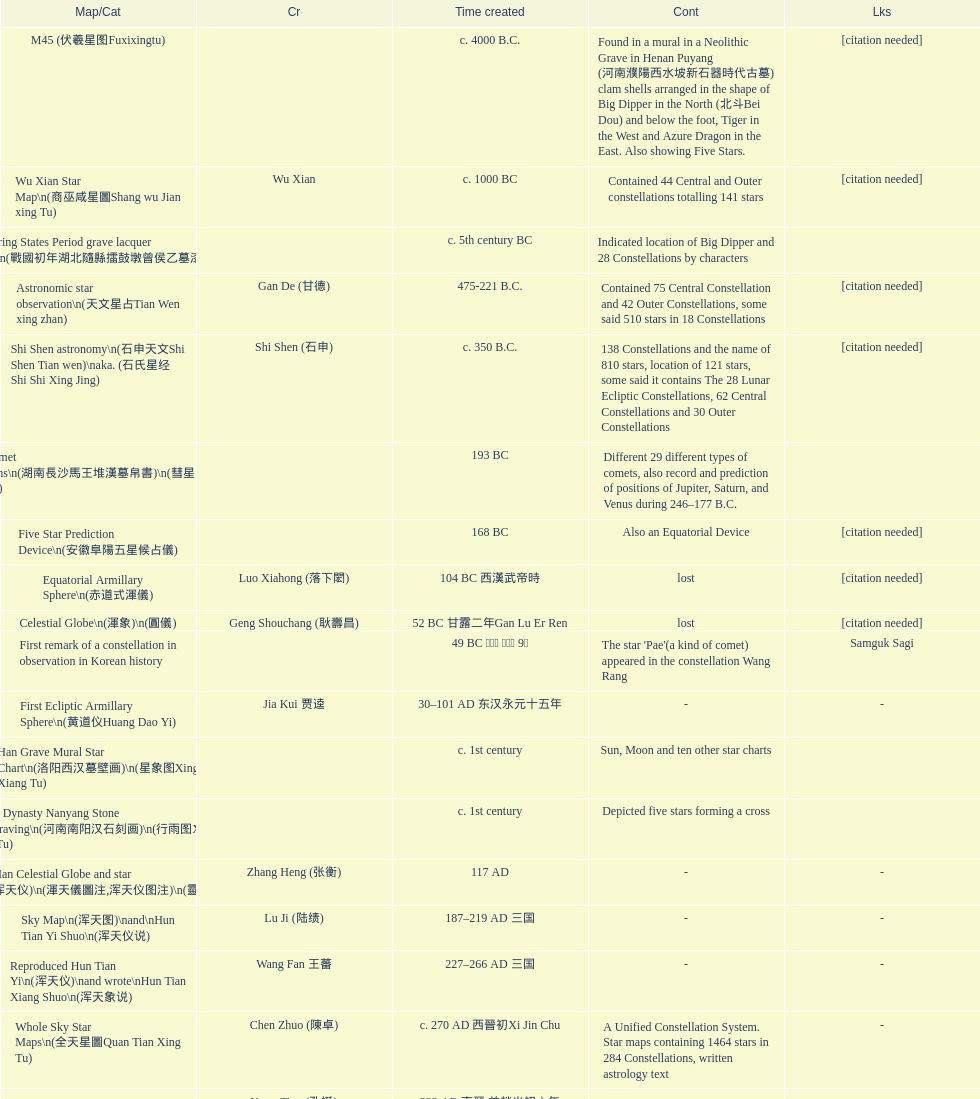Which was the first chinese star map known to have been created? M45 (伏羲星图Fuxixingtu). 